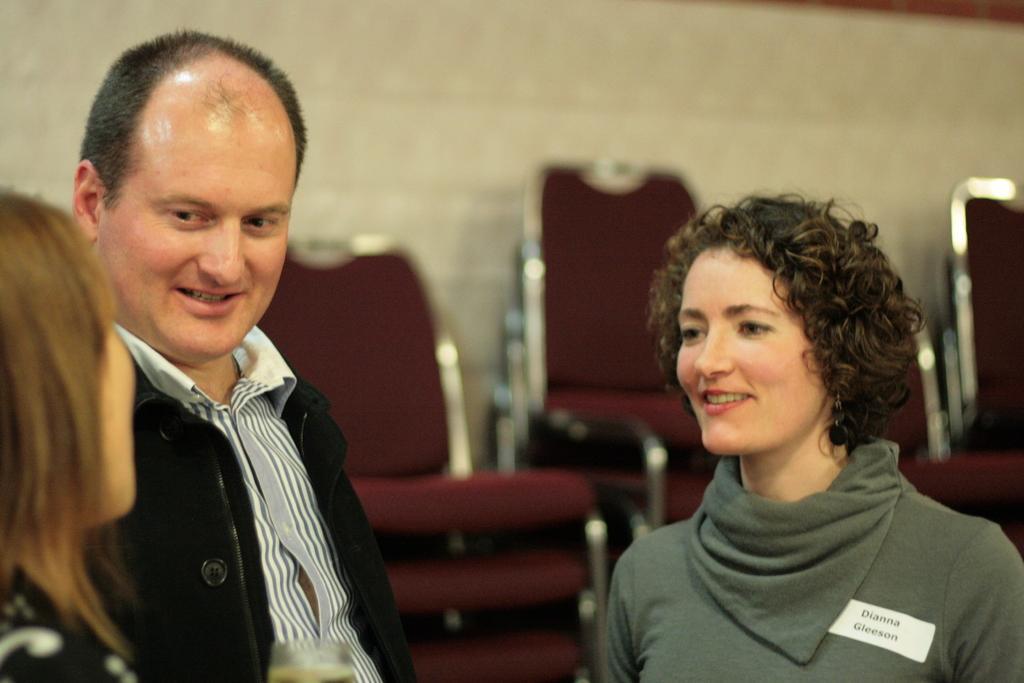Could you give a brief overview of what you see in this image? In this picture we can see three people, two people are smiling and in the background we can see chairs and the wall. 